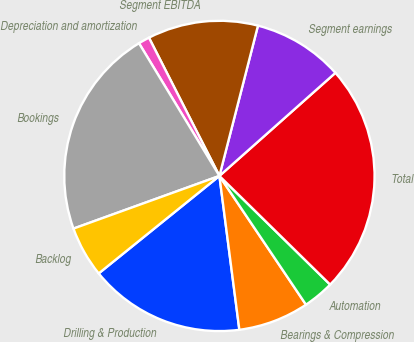<chart> <loc_0><loc_0><loc_500><loc_500><pie_chart><fcel>Drilling & Production<fcel>Bearings & Compression<fcel>Automation<fcel>Total<fcel>Segment earnings<fcel>Segment EBITDA<fcel>Depreciation and amortization<fcel>Bookings<fcel>Backlog<nl><fcel>16.24%<fcel>7.37%<fcel>3.23%<fcel>23.91%<fcel>9.44%<fcel>11.5%<fcel>1.17%<fcel>21.84%<fcel>5.3%<nl></chart> 